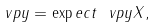Convert formula to latex. <formula><loc_0><loc_0><loc_500><loc_500>\ v p y = \exp e c t { \ v p y X } ,</formula> 